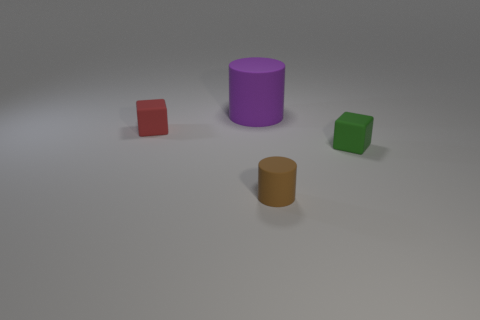Add 2 green things. How many objects exist? 6 Subtract all red blocks. How many blocks are left? 1 Subtract 1 cylinders. How many cylinders are left? 1 Add 1 matte objects. How many matte objects are left? 5 Add 2 tiny rubber blocks. How many tiny rubber blocks exist? 4 Subtract 0 green balls. How many objects are left? 4 Subtract all cyan blocks. Subtract all green balls. How many blocks are left? 2 Subtract all green cubes. How many purple cylinders are left? 1 Subtract all small green rubber cubes. Subtract all large green shiny blocks. How many objects are left? 3 